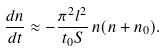<formula> <loc_0><loc_0><loc_500><loc_500>\frac { d n } { d t } \approx - \frac { \pi ^ { 2 } l ^ { 2 } } { t _ { 0 } S } \, n ( n + n _ { 0 } ) .</formula> 